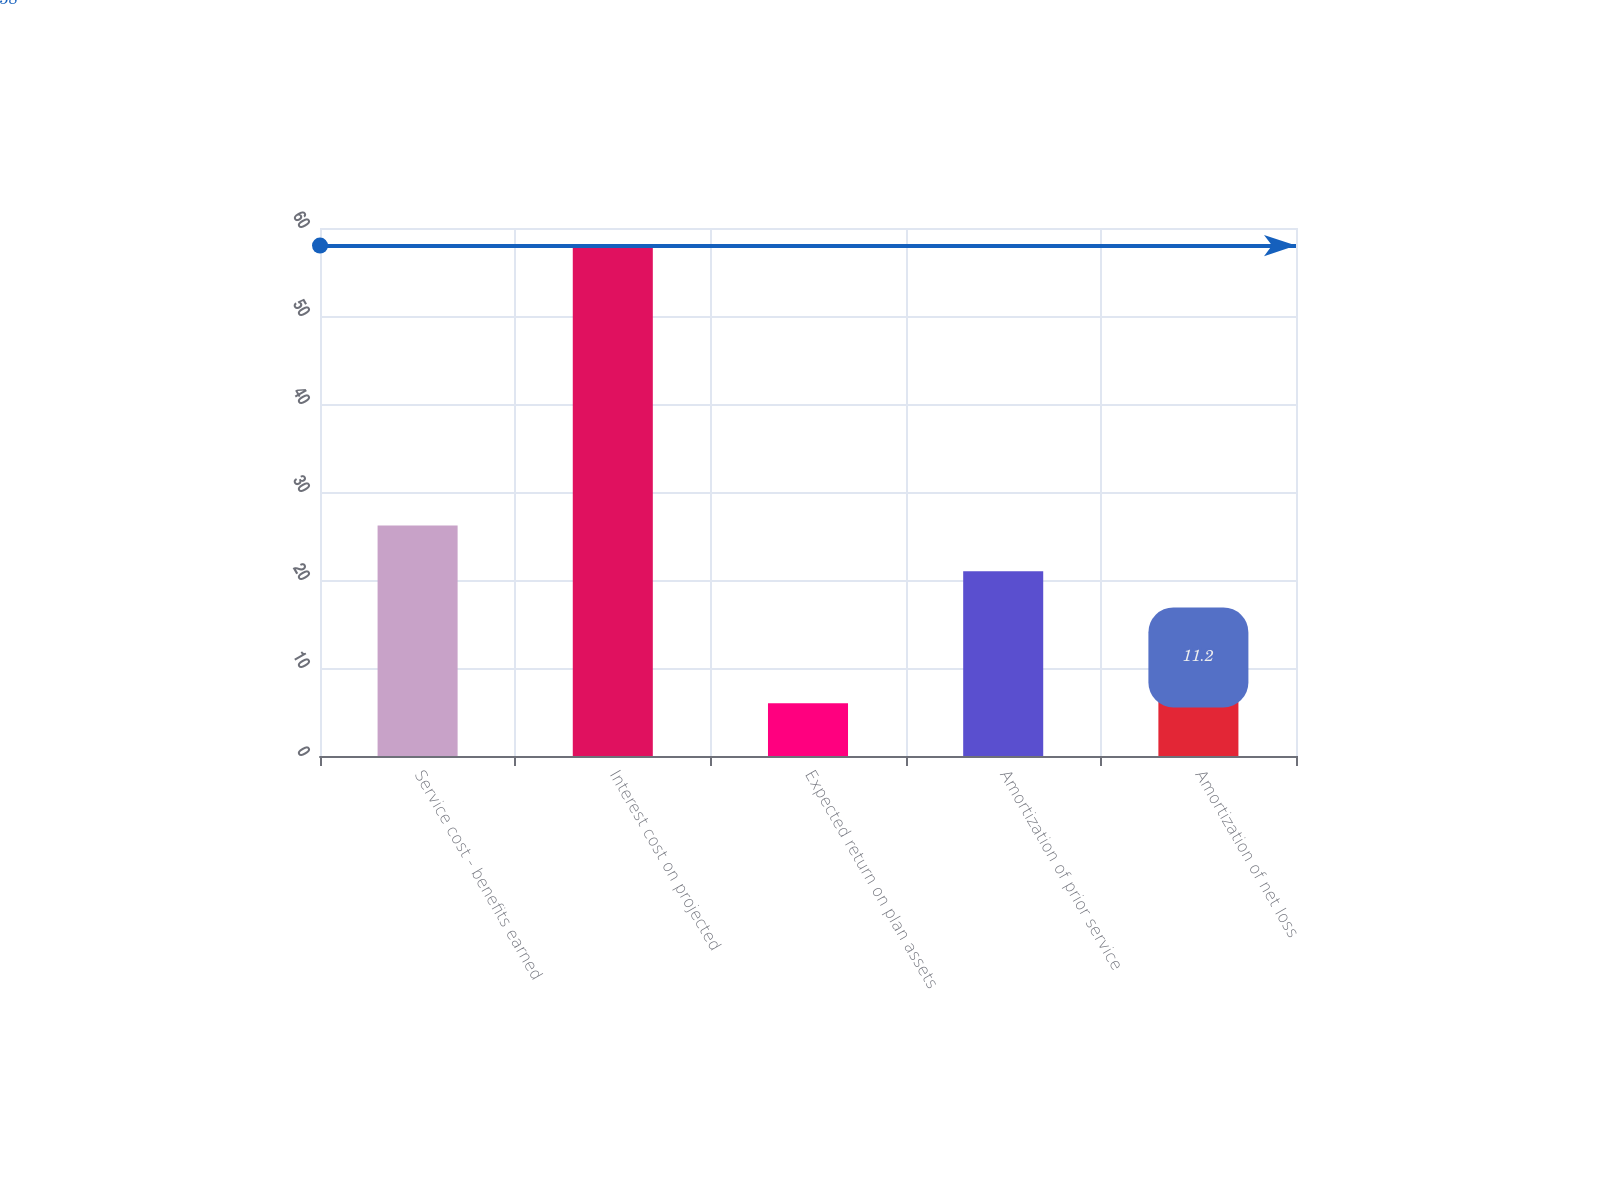<chart> <loc_0><loc_0><loc_500><loc_500><bar_chart><fcel>Service cost - benefits earned<fcel>Interest cost on projected<fcel>Expected return on plan assets<fcel>Amortization of prior service<fcel>Amortization of net loss<nl><fcel>26.2<fcel>58<fcel>6<fcel>21<fcel>11.2<nl></chart> 